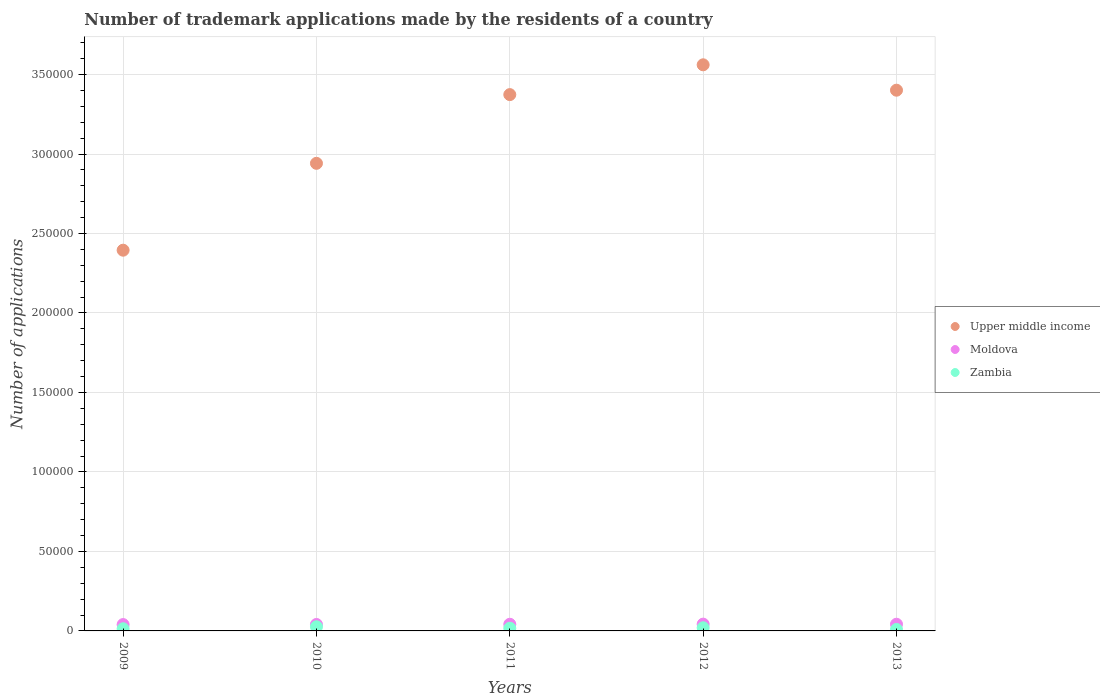How many different coloured dotlines are there?
Offer a very short reply. 3. What is the number of trademark applications made by the residents in Moldova in 2011?
Your response must be concise. 4183. Across all years, what is the maximum number of trademark applications made by the residents in Upper middle income?
Your answer should be very brief. 3.56e+05. Across all years, what is the minimum number of trademark applications made by the residents in Zambia?
Keep it short and to the point. 944. In which year was the number of trademark applications made by the residents in Zambia maximum?
Make the answer very short. 2010. In which year was the number of trademark applications made by the residents in Zambia minimum?
Make the answer very short. 2013. What is the total number of trademark applications made by the residents in Moldova in the graph?
Give a very brief answer. 2.07e+04. What is the difference between the number of trademark applications made by the residents in Zambia in 2010 and that in 2013?
Your answer should be very brief. 1668. What is the difference between the number of trademark applications made by the residents in Zambia in 2012 and the number of trademark applications made by the residents in Upper middle income in 2010?
Your answer should be very brief. -2.92e+05. What is the average number of trademark applications made by the residents in Moldova per year?
Provide a succinct answer. 4142.8. In the year 2013, what is the difference between the number of trademark applications made by the residents in Moldova and number of trademark applications made by the residents in Upper middle income?
Your answer should be compact. -3.36e+05. In how many years, is the number of trademark applications made by the residents in Upper middle income greater than 10000?
Ensure brevity in your answer.  5. What is the ratio of the number of trademark applications made by the residents in Moldova in 2009 to that in 2013?
Your answer should be compact. 0.95. What is the difference between the highest and the second highest number of trademark applications made by the residents in Moldova?
Provide a succinct answer. 63. What is the difference between the highest and the lowest number of trademark applications made by the residents in Zambia?
Your response must be concise. 1668. Is the sum of the number of trademark applications made by the residents in Moldova in 2009 and 2010 greater than the maximum number of trademark applications made by the residents in Zambia across all years?
Your response must be concise. Yes. How many dotlines are there?
Give a very brief answer. 3. Are the values on the major ticks of Y-axis written in scientific E-notation?
Offer a very short reply. No. Does the graph contain grids?
Give a very brief answer. Yes. How many legend labels are there?
Offer a terse response. 3. What is the title of the graph?
Your response must be concise. Number of trademark applications made by the residents of a country. What is the label or title of the Y-axis?
Provide a succinct answer. Number of applications. What is the Number of applications in Upper middle income in 2009?
Ensure brevity in your answer.  2.40e+05. What is the Number of applications of Moldova in 2009?
Give a very brief answer. 3996. What is the Number of applications of Zambia in 2009?
Keep it short and to the point. 1365. What is the Number of applications in Upper middle income in 2010?
Your answer should be very brief. 2.94e+05. What is the Number of applications in Moldova in 2010?
Provide a succinct answer. 4058. What is the Number of applications of Zambia in 2010?
Offer a terse response. 2612. What is the Number of applications of Upper middle income in 2011?
Keep it short and to the point. 3.37e+05. What is the Number of applications of Moldova in 2011?
Provide a succinct answer. 4183. What is the Number of applications in Zambia in 2011?
Ensure brevity in your answer.  1690. What is the Number of applications of Upper middle income in 2012?
Ensure brevity in your answer.  3.56e+05. What is the Number of applications in Moldova in 2012?
Ensure brevity in your answer.  4270. What is the Number of applications in Zambia in 2012?
Keep it short and to the point. 1978. What is the Number of applications in Upper middle income in 2013?
Offer a terse response. 3.40e+05. What is the Number of applications of Moldova in 2013?
Your answer should be compact. 4207. What is the Number of applications of Zambia in 2013?
Ensure brevity in your answer.  944. Across all years, what is the maximum Number of applications in Upper middle income?
Your answer should be compact. 3.56e+05. Across all years, what is the maximum Number of applications of Moldova?
Provide a succinct answer. 4270. Across all years, what is the maximum Number of applications of Zambia?
Ensure brevity in your answer.  2612. Across all years, what is the minimum Number of applications in Upper middle income?
Your answer should be very brief. 2.40e+05. Across all years, what is the minimum Number of applications in Moldova?
Give a very brief answer. 3996. Across all years, what is the minimum Number of applications of Zambia?
Provide a succinct answer. 944. What is the total Number of applications in Upper middle income in the graph?
Make the answer very short. 1.57e+06. What is the total Number of applications of Moldova in the graph?
Your answer should be compact. 2.07e+04. What is the total Number of applications of Zambia in the graph?
Keep it short and to the point. 8589. What is the difference between the Number of applications in Upper middle income in 2009 and that in 2010?
Ensure brevity in your answer.  -5.47e+04. What is the difference between the Number of applications in Moldova in 2009 and that in 2010?
Make the answer very short. -62. What is the difference between the Number of applications of Zambia in 2009 and that in 2010?
Make the answer very short. -1247. What is the difference between the Number of applications of Upper middle income in 2009 and that in 2011?
Your answer should be compact. -9.79e+04. What is the difference between the Number of applications in Moldova in 2009 and that in 2011?
Offer a terse response. -187. What is the difference between the Number of applications in Zambia in 2009 and that in 2011?
Offer a very short reply. -325. What is the difference between the Number of applications of Upper middle income in 2009 and that in 2012?
Your answer should be compact. -1.17e+05. What is the difference between the Number of applications of Moldova in 2009 and that in 2012?
Your answer should be compact. -274. What is the difference between the Number of applications of Zambia in 2009 and that in 2012?
Keep it short and to the point. -613. What is the difference between the Number of applications in Upper middle income in 2009 and that in 2013?
Your response must be concise. -1.01e+05. What is the difference between the Number of applications in Moldova in 2009 and that in 2013?
Provide a short and direct response. -211. What is the difference between the Number of applications in Zambia in 2009 and that in 2013?
Provide a succinct answer. 421. What is the difference between the Number of applications in Upper middle income in 2010 and that in 2011?
Your answer should be compact. -4.32e+04. What is the difference between the Number of applications in Moldova in 2010 and that in 2011?
Provide a succinct answer. -125. What is the difference between the Number of applications of Zambia in 2010 and that in 2011?
Provide a short and direct response. 922. What is the difference between the Number of applications in Upper middle income in 2010 and that in 2012?
Make the answer very short. -6.20e+04. What is the difference between the Number of applications of Moldova in 2010 and that in 2012?
Make the answer very short. -212. What is the difference between the Number of applications in Zambia in 2010 and that in 2012?
Your answer should be very brief. 634. What is the difference between the Number of applications of Upper middle income in 2010 and that in 2013?
Your response must be concise. -4.60e+04. What is the difference between the Number of applications in Moldova in 2010 and that in 2013?
Give a very brief answer. -149. What is the difference between the Number of applications in Zambia in 2010 and that in 2013?
Offer a very short reply. 1668. What is the difference between the Number of applications of Upper middle income in 2011 and that in 2012?
Offer a very short reply. -1.88e+04. What is the difference between the Number of applications of Moldova in 2011 and that in 2012?
Ensure brevity in your answer.  -87. What is the difference between the Number of applications of Zambia in 2011 and that in 2012?
Offer a terse response. -288. What is the difference between the Number of applications of Upper middle income in 2011 and that in 2013?
Provide a succinct answer. -2777. What is the difference between the Number of applications in Moldova in 2011 and that in 2013?
Keep it short and to the point. -24. What is the difference between the Number of applications in Zambia in 2011 and that in 2013?
Keep it short and to the point. 746. What is the difference between the Number of applications of Upper middle income in 2012 and that in 2013?
Keep it short and to the point. 1.60e+04. What is the difference between the Number of applications of Zambia in 2012 and that in 2013?
Provide a short and direct response. 1034. What is the difference between the Number of applications in Upper middle income in 2009 and the Number of applications in Moldova in 2010?
Ensure brevity in your answer.  2.35e+05. What is the difference between the Number of applications of Upper middle income in 2009 and the Number of applications of Zambia in 2010?
Your response must be concise. 2.37e+05. What is the difference between the Number of applications of Moldova in 2009 and the Number of applications of Zambia in 2010?
Provide a succinct answer. 1384. What is the difference between the Number of applications of Upper middle income in 2009 and the Number of applications of Moldova in 2011?
Offer a very short reply. 2.35e+05. What is the difference between the Number of applications of Upper middle income in 2009 and the Number of applications of Zambia in 2011?
Your answer should be compact. 2.38e+05. What is the difference between the Number of applications in Moldova in 2009 and the Number of applications in Zambia in 2011?
Your answer should be very brief. 2306. What is the difference between the Number of applications of Upper middle income in 2009 and the Number of applications of Moldova in 2012?
Offer a terse response. 2.35e+05. What is the difference between the Number of applications in Upper middle income in 2009 and the Number of applications in Zambia in 2012?
Keep it short and to the point. 2.38e+05. What is the difference between the Number of applications in Moldova in 2009 and the Number of applications in Zambia in 2012?
Make the answer very short. 2018. What is the difference between the Number of applications in Upper middle income in 2009 and the Number of applications in Moldova in 2013?
Make the answer very short. 2.35e+05. What is the difference between the Number of applications in Upper middle income in 2009 and the Number of applications in Zambia in 2013?
Provide a succinct answer. 2.39e+05. What is the difference between the Number of applications of Moldova in 2009 and the Number of applications of Zambia in 2013?
Offer a terse response. 3052. What is the difference between the Number of applications in Upper middle income in 2010 and the Number of applications in Moldova in 2011?
Your response must be concise. 2.90e+05. What is the difference between the Number of applications in Upper middle income in 2010 and the Number of applications in Zambia in 2011?
Make the answer very short. 2.92e+05. What is the difference between the Number of applications of Moldova in 2010 and the Number of applications of Zambia in 2011?
Offer a very short reply. 2368. What is the difference between the Number of applications of Upper middle income in 2010 and the Number of applications of Moldova in 2012?
Offer a very short reply. 2.90e+05. What is the difference between the Number of applications of Upper middle income in 2010 and the Number of applications of Zambia in 2012?
Ensure brevity in your answer.  2.92e+05. What is the difference between the Number of applications of Moldova in 2010 and the Number of applications of Zambia in 2012?
Ensure brevity in your answer.  2080. What is the difference between the Number of applications in Upper middle income in 2010 and the Number of applications in Moldova in 2013?
Provide a short and direct response. 2.90e+05. What is the difference between the Number of applications in Upper middle income in 2010 and the Number of applications in Zambia in 2013?
Offer a terse response. 2.93e+05. What is the difference between the Number of applications of Moldova in 2010 and the Number of applications of Zambia in 2013?
Give a very brief answer. 3114. What is the difference between the Number of applications in Upper middle income in 2011 and the Number of applications in Moldova in 2012?
Your answer should be compact. 3.33e+05. What is the difference between the Number of applications of Upper middle income in 2011 and the Number of applications of Zambia in 2012?
Ensure brevity in your answer.  3.35e+05. What is the difference between the Number of applications of Moldova in 2011 and the Number of applications of Zambia in 2012?
Your answer should be compact. 2205. What is the difference between the Number of applications of Upper middle income in 2011 and the Number of applications of Moldova in 2013?
Offer a terse response. 3.33e+05. What is the difference between the Number of applications of Upper middle income in 2011 and the Number of applications of Zambia in 2013?
Give a very brief answer. 3.36e+05. What is the difference between the Number of applications in Moldova in 2011 and the Number of applications in Zambia in 2013?
Make the answer very short. 3239. What is the difference between the Number of applications in Upper middle income in 2012 and the Number of applications in Moldova in 2013?
Make the answer very short. 3.52e+05. What is the difference between the Number of applications in Upper middle income in 2012 and the Number of applications in Zambia in 2013?
Offer a terse response. 3.55e+05. What is the difference between the Number of applications in Moldova in 2012 and the Number of applications in Zambia in 2013?
Offer a very short reply. 3326. What is the average Number of applications in Upper middle income per year?
Offer a terse response. 3.13e+05. What is the average Number of applications of Moldova per year?
Your answer should be compact. 4142.8. What is the average Number of applications in Zambia per year?
Offer a very short reply. 1717.8. In the year 2009, what is the difference between the Number of applications in Upper middle income and Number of applications in Moldova?
Your response must be concise. 2.36e+05. In the year 2009, what is the difference between the Number of applications in Upper middle income and Number of applications in Zambia?
Provide a short and direct response. 2.38e+05. In the year 2009, what is the difference between the Number of applications of Moldova and Number of applications of Zambia?
Your response must be concise. 2631. In the year 2010, what is the difference between the Number of applications in Upper middle income and Number of applications in Moldova?
Make the answer very short. 2.90e+05. In the year 2010, what is the difference between the Number of applications in Upper middle income and Number of applications in Zambia?
Your answer should be very brief. 2.92e+05. In the year 2010, what is the difference between the Number of applications of Moldova and Number of applications of Zambia?
Your answer should be very brief. 1446. In the year 2011, what is the difference between the Number of applications in Upper middle income and Number of applications in Moldova?
Your response must be concise. 3.33e+05. In the year 2011, what is the difference between the Number of applications of Upper middle income and Number of applications of Zambia?
Your answer should be very brief. 3.36e+05. In the year 2011, what is the difference between the Number of applications of Moldova and Number of applications of Zambia?
Give a very brief answer. 2493. In the year 2012, what is the difference between the Number of applications of Upper middle income and Number of applications of Moldova?
Offer a very short reply. 3.52e+05. In the year 2012, what is the difference between the Number of applications of Upper middle income and Number of applications of Zambia?
Offer a very short reply. 3.54e+05. In the year 2012, what is the difference between the Number of applications of Moldova and Number of applications of Zambia?
Your answer should be compact. 2292. In the year 2013, what is the difference between the Number of applications in Upper middle income and Number of applications in Moldova?
Offer a terse response. 3.36e+05. In the year 2013, what is the difference between the Number of applications of Upper middle income and Number of applications of Zambia?
Your response must be concise. 3.39e+05. In the year 2013, what is the difference between the Number of applications in Moldova and Number of applications in Zambia?
Offer a very short reply. 3263. What is the ratio of the Number of applications in Upper middle income in 2009 to that in 2010?
Your response must be concise. 0.81. What is the ratio of the Number of applications in Moldova in 2009 to that in 2010?
Provide a short and direct response. 0.98. What is the ratio of the Number of applications of Zambia in 2009 to that in 2010?
Offer a very short reply. 0.52. What is the ratio of the Number of applications of Upper middle income in 2009 to that in 2011?
Ensure brevity in your answer.  0.71. What is the ratio of the Number of applications in Moldova in 2009 to that in 2011?
Your response must be concise. 0.96. What is the ratio of the Number of applications in Zambia in 2009 to that in 2011?
Give a very brief answer. 0.81. What is the ratio of the Number of applications of Upper middle income in 2009 to that in 2012?
Offer a terse response. 0.67. What is the ratio of the Number of applications in Moldova in 2009 to that in 2012?
Offer a terse response. 0.94. What is the ratio of the Number of applications in Zambia in 2009 to that in 2012?
Your answer should be compact. 0.69. What is the ratio of the Number of applications of Upper middle income in 2009 to that in 2013?
Keep it short and to the point. 0.7. What is the ratio of the Number of applications in Moldova in 2009 to that in 2013?
Offer a very short reply. 0.95. What is the ratio of the Number of applications in Zambia in 2009 to that in 2013?
Offer a terse response. 1.45. What is the ratio of the Number of applications in Upper middle income in 2010 to that in 2011?
Provide a short and direct response. 0.87. What is the ratio of the Number of applications in Moldova in 2010 to that in 2011?
Offer a very short reply. 0.97. What is the ratio of the Number of applications of Zambia in 2010 to that in 2011?
Provide a succinct answer. 1.55. What is the ratio of the Number of applications of Upper middle income in 2010 to that in 2012?
Give a very brief answer. 0.83. What is the ratio of the Number of applications of Moldova in 2010 to that in 2012?
Offer a terse response. 0.95. What is the ratio of the Number of applications in Zambia in 2010 to that in 2012?
Give a very brief answer. 1.32. What is the ratio of the Number of applications of Upper middle income in 2010 to that in 2013?
Give a very brief answer. 0.86. What is the ratio of the Number of applications of Moldova in 2010 to that in 2013?
Give a very brief answer. 0.96. What is the ratio of the Number of applications of Zambia in 2010 to that in 2013?
Ensure brevity in your answer.  2.77. What is the ratio of the Number of applications in Moldova in 2011 to that in 2012?
Ensure brevity in your answer.  0.98. What is the ratio of the Number of applications of Zambia in 2011 to that in 2012?
Provide a short and direct response. 0.85. What is the ratio of the Number of applications in Upper middle income in 2011 to that in 2013?
Your answer should be compact. 0.99. What is the ratio of the Number of applications of Moldova in 2011 to that in 2013?
Your response must be concise. 0.99. What is the ratio of the Number of applications in Zambia in 2011 to that in 2013?
Give a very brief answer. 1.79. What is the ratio of the Number of applications in Upper middle income in 2012 to that in 2013?
Ensure brevity in your answer.  1.05. What is the ratio of the Number of applications in Moldova in 2012 to that in 2013?
Give a very brief answer. 1.01. What is the ratio of the Number of applications of Zambia in 2012 to that in 2013?
Make the answer very short. 2.1. What is the difference between the highest and the second highest Number of applications of Upper middle income?
Make the answer very short. 1.60e+04. What is the difference between the highest and the second highest Number of applications in Moldova?
Keep it short and to the point. 63. What is the difference between the highest and the second highest Number of applications in Zambia?
Your answer should be compact. 634. What is the difference between the highest and the lowest Number of applications of Upper middle income?
Ensure brevity in your answer.  1.17e+05. What is the difference between the highest and the lowest Number of applications of Moldova?
Your answer should be compact. 274. What is the difference between the highest and the lowest Number of applications in Zambia?
Provide a succinct answer. 1668. 